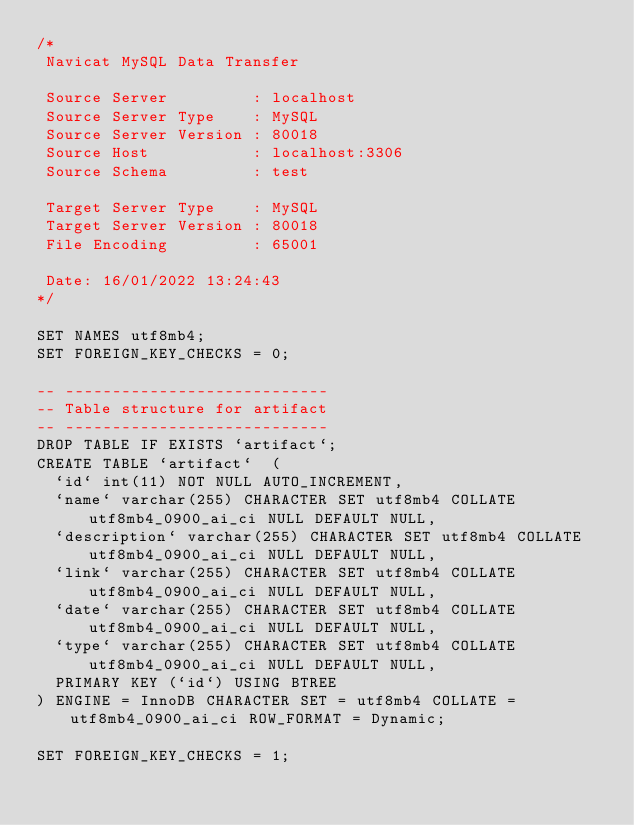<code> <loc_0><loc_0><loc_500><loc_500><_SQL_>/*
 Navicat MySQL Data Transfer

 Source Server         : localhost
 Source Server Type    : MySQL
 Source Server Version : 80018
 Source Host           : localhost:3306
 Source Schema         : test

 Target Server Type    : MySQL
 Target Server Version : 80018
 File Encoding         : 65001

 Date: 16/01/2022 13:24:43
*/

SET NAMES utf8mb4;
SET FOREIGN_KEY_CHECKS = 0;

-- ----------------------------
-- Table structure for artifact
-- ----------------------------
DROP TABLE IF EXISTS `artifact`;
CREATE TABLE `artifact`  (
  `id` int(11) NOT NULL AUTO_INCREMENT,
  `name` varchar(255) CHARACTER SET utf8mb4 COLLATE utf8mb4_0900_ai_ci NULL DEFAULT NULL,
  `description` varchar(255) CHARACTER SET utf8mb4 COLLATE utf8mb4_0900_ai_ci NULL DEFAULT NULL,
  `link` varchar(255) CHARACTER SET utf8mb4 COLLATE utf8mb4_0900_ai_ci NULL DEFAULT NULL,
  `date` varchar(255) CHARACTER SET utf8mb4 COLLATE utf8mb4_0900_ai_ci NULL DEFAULT NULL,
  `type` varchar(255) CHARACTER SET utf8mb4 COLLATE utf8mb4_0900_ai_ci NULL DEFAULT NULL,
  PRIMARY KEY (`id`) USING BTREE
) ENGINE = InnoDB CHARACTER SET = utf8mb4 COLLATE = utf8mb4_0900_ai_ci ROW_FORMAT = Dynamic;

SET FOREIGN_KEY_CHECKS = 1;
</code> 